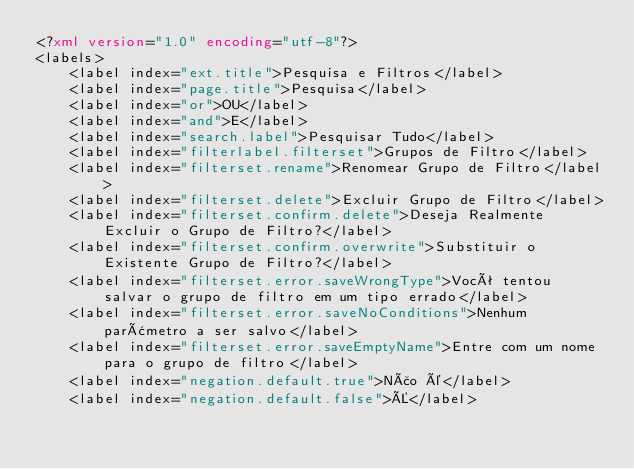<code> <loc_0><loc_0><loc_500><loc_500><_XML_><?xml version="1.0" encoding="utf-8"?>
<labels>
	<label index="ext.title">Pesquisa e Filtros</label>
	<label index="page.title">Pesquisa</label>
	<label index="or">OU</label>
	<label index="and">E</label>
	<label index="search.label">Pesquisar Tudo</label>
	<label index="filterlabel.filterset">Grupos de Filtro</label>
	<label index="filterset.rename">Renomear Grupo de Filtro</label>
	<label index="filterset.delete">Excluir Grupo de Filtro</label>
	<label index="filterset.confirm.delete">Deseja Realmente Excluir o Grupo de Filtro?</label>
	<label index="filterset.confirm.overwrite">Substituir o Existente Grupo de Filtro?</label>
	<label index="filterset.error.saveWrongType">Você tentou salvar o grupo de filtro em um tipo errado</label>
	<label index="filterset.error.saveNoConditions">Nenhum parâmetro a ser salvo</label>
	<label index="filterset.error.saveEmptyName">Entre com um nome para o grupo de filtro</label>
	<label index="negation.default.true">Não é</label>
	<label index="negation.default.false">É</label></code> 